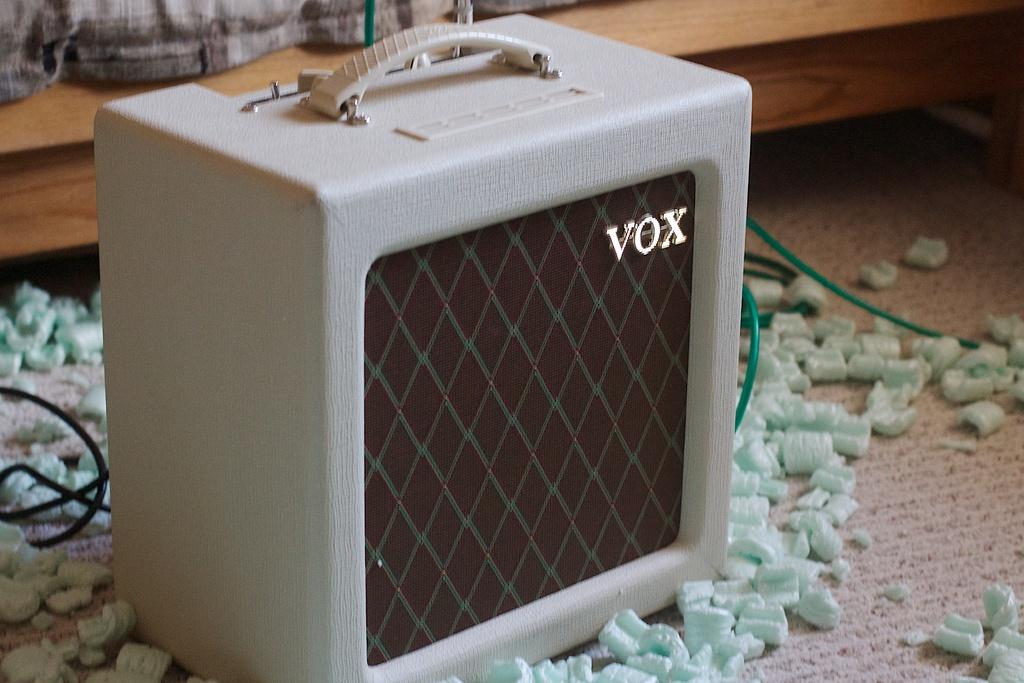What is the main object in the image? There is a box in the image. What else can be seen in the image besides the box? There are cables and objects on the floor in the image. What can be seen in the background of the image? There is a wooden object and cloth in the background of the image. What type of drink is being served in the image? There is no drink present in the image. What kind of animal can be seen interacting with the objects in the image? There are no animals present in the image. 